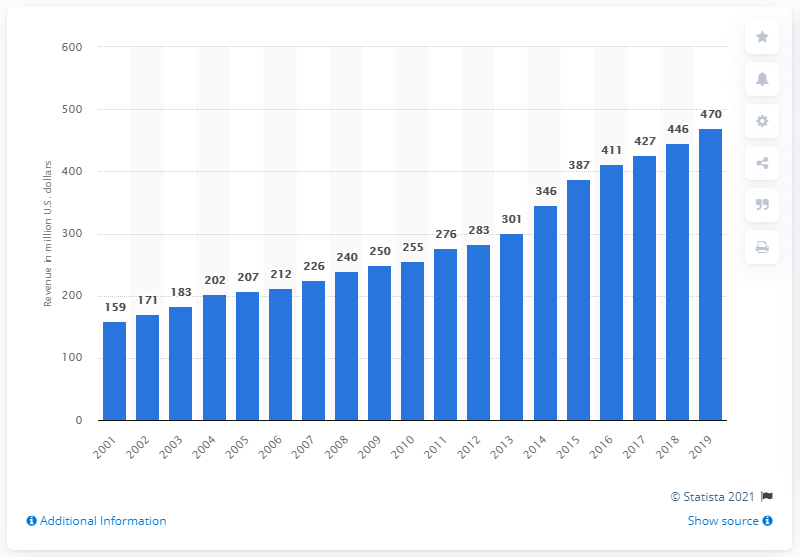Indicate a few pertinent items in this graphic. The Denver Broncos became a franchise of the National Football League in 2001. The revenue of the Denver Broncos in 2019 was approximately 470 million dollars. 